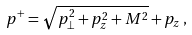Convert formula to latex. <formula><loc_0><loc_0><loc_500><loc_500>p ^ { + } = \sqrt { { p } _ { \perp } ^ { 2 } + p _ { z } ^ { 2 } + M ^ { 2 } } + p _ { z } \, ,</formula> 